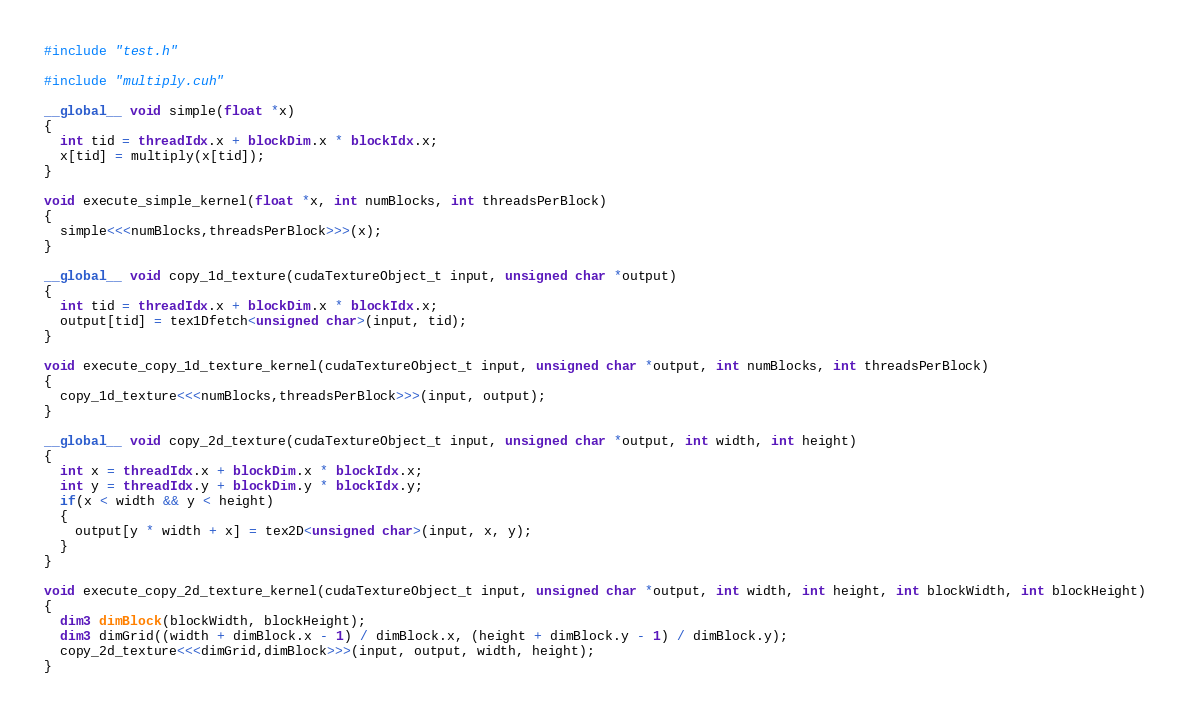Convert code to text. <code><loc_0><loc_0><loc_500><loc_500><_Cuda_>#include "test.h"

#include "multiply.cuh"

__global__ void simple(float *x)
{
  int tid = threadIdx.x + blockDim.x * blockIdx.x;
  x[tid] = multiply(x[tid]);
}

void execute_simple_kernel(float *x, int numBlocks, int threadsPerBlock)
{
  simple<<<numBlocks,threadsPerBlock>>>(x);
}

__global__ void copy_1d_texture(cudaTextureObject_t input, unsigned char *output)
{
  int tid = threadIdx.x + blockDim.x * blockIdx.x;
  output[tid] = tex1Dfetch<unsigned char>(input, tid);
}

void execute_copy_1d_texture_kernel(cudaTextureObject_t input, unsigned char *output, int numBlocks, int threadsPerBlock)
{
  copy_1d_texture<<<numBlocks,threadsPerBlock>>>(input, output);
}

__global__ void copy_2d_texture(cudaTextureObject_t input, unsigned char *output, int width, int height)
{
  int x = threadIdx.x + blockDim.x * blockIdx.x;
  int y = threadIdx.y + blockDim.y * blockIdx.y;
  if(x < width && y < height)
  {
    output[y * width + x] = tex2D<unsigned char>(input, x, y);
  }
}

void execute_copy_2d_texture_kernel(cudaTextureObject_t input, unsigned char *output, int width, int height, int blockWidth, int blockHeight)
{
  dim3 dimBlock(blockWidth, blockHeight);
  dim3 dimGrid((width + dimBlock.x - 1) / dimBlock.x, (height + dimBlock.y - 1) / dimBlock.y);
  copy_2d_texture<<<dimGrid,dimBlock>>>(input, output, width, height);
}
</code> 